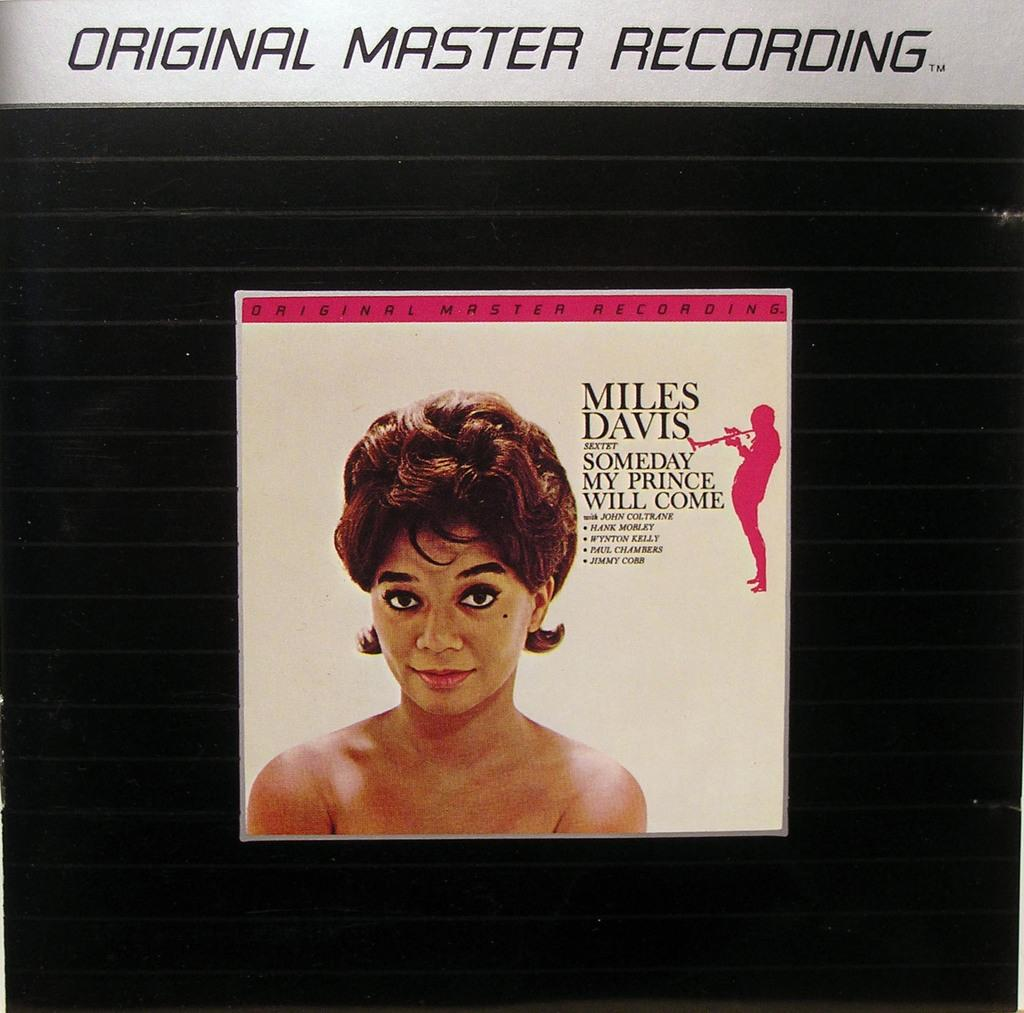Who is present in the image? There is a woman in the image. What else can be seen in the image besides the woman? There is text and a person holding a musical instrument in the image. What type of faucet is visible in the image? There is no faucet present in the image. How does the woman start playing the musical instrument in the image? The image does not show the woman starting to play the musical instrument, so it cannot be determined from the image. 